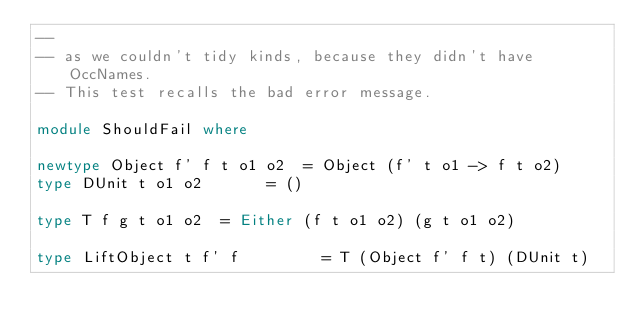Convert code to text. <code><loc_0><loc_0><loc_500><loc_500><_Haskell_>--
-- as we couldn't tidy kinds, because they didn't have OccNames.
-- This test recalls the bad error message.

module ShouldFail where

newtype Object f' f t o1 o2  = Object (f' t o1 -> f t o2)
type DUnit t o1 o2       = ()

type T f g t o1 o2  = Either (f t o1 o2) (g t o1 o2)

type LiftObject t f' f         = T (Object f' f t) (DUnit t)


</code> 